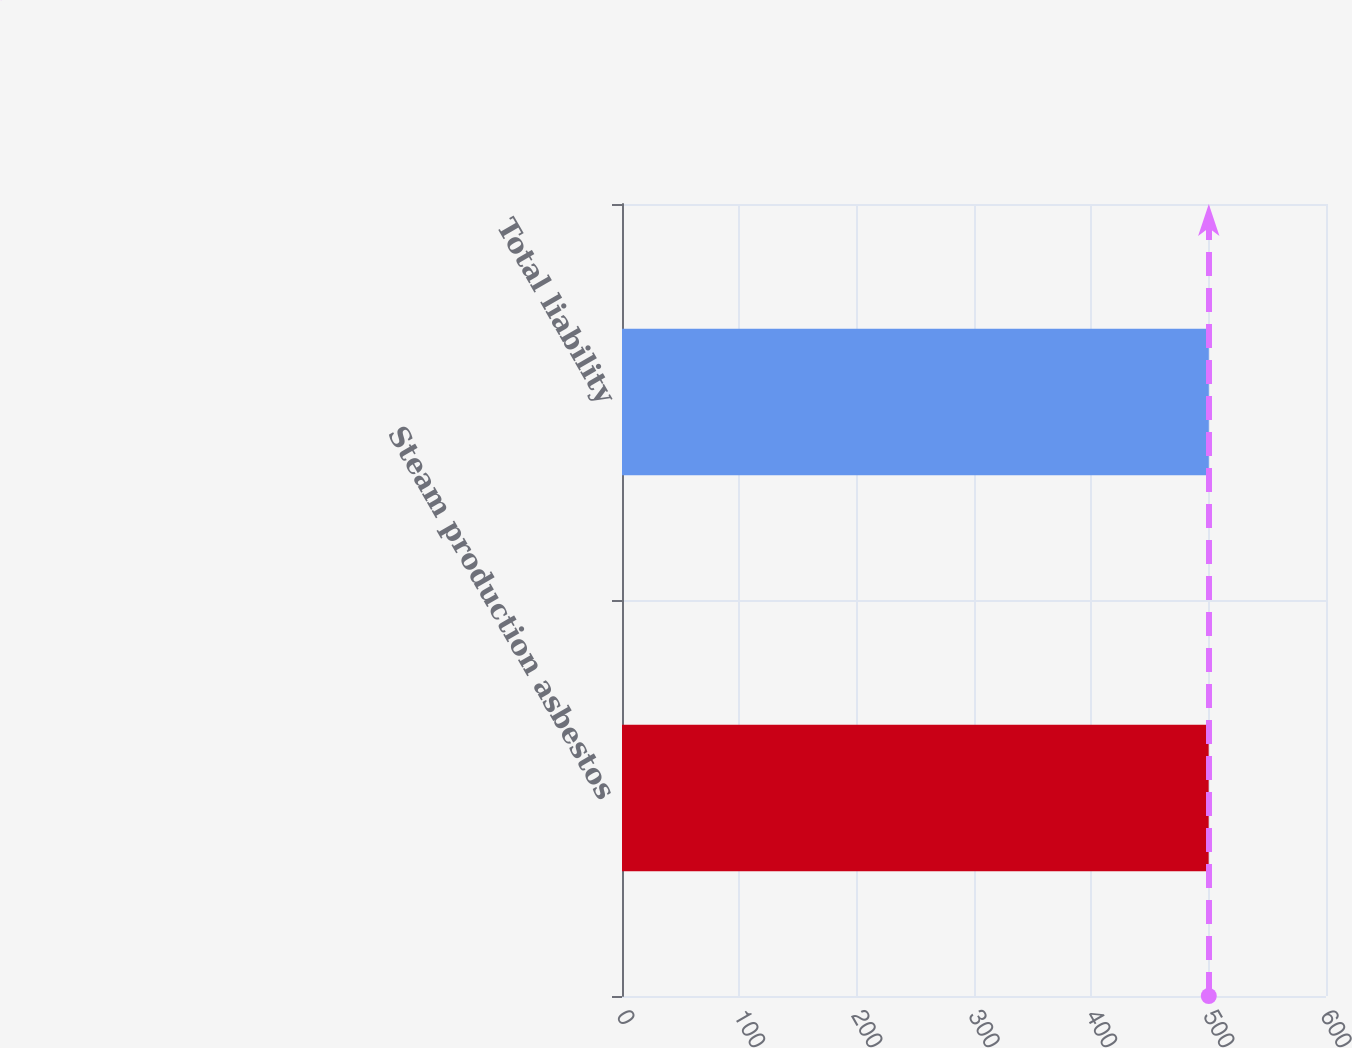<chart> <loc_0><loc_0><loc_500><loc_500><bar_chart><fcel>Steam production asbestos<fcel>Total liability<nl><fcel>500<fcel>500.1<nl></chart> 